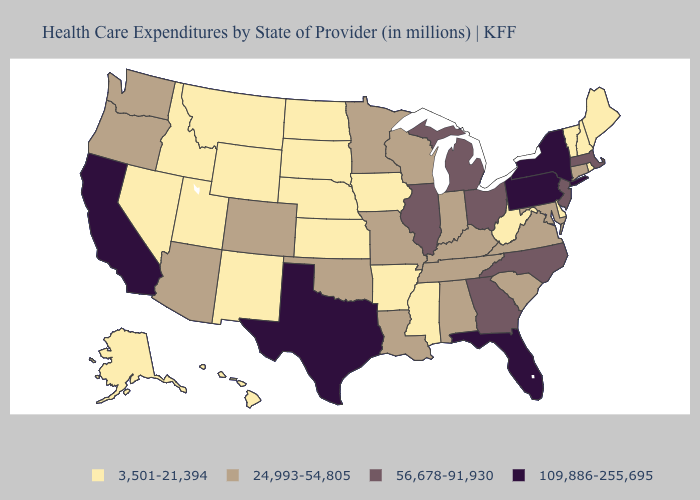Does Oregon have a lower value than Mississippi?
Answer briefly. No. What is the lowest value in the USA?
Short answer required. 3,501-21,394. Name the states that have a value in the range 56,678-91,930?
Quick response, please. Georgia, Illinois, Massachusetts, Michigan, New Jersey, North Carolina, Ohio. Name the states that have a value in the range 3,501-21,394?
Write a very short answer. Alaska, Arkansas, Delaware, Hawaii, Idaho, Iowa, Kansas, Maine, Mississippi, Montana, Nebraska, Nevada, New Hampshire, New Mexico, North Dakota, Rhode Island, South Dakota, Utah, Vermont, West Virginia, Wyoming. Is the legend a continuous bar?
Short answer required. No. Which states have the lowest value in the USA?
Give a very brief answer. Alaska, Arkansas, Delaware, Hawaii, Idaho, Iowa, Kansas, Maine, Mississippi, Montana, Nebraska, Nevada, New Hampshire, New Mexico, North Dakota, Rhode Island, South Dakota, Utah, Vermont, West Virginia, Wyoming. Does Illinois have the highest value in the MidWest?
Quick response, please. Yes. Does South Dakota have the highest value in the USA?
Concise answer only. No. Does Indiana have the highest value in the USA?
Answer briefly. No. What is the highest value in the South ?
Be succinct. 109,886-255,695. Name the states that have a value in the range 24,993-54,805?
Concise answer only. Alabama, Arizona, Colorado, Connecticut, Indiana, Kentucky, Louisiana, Maryland, Minnesota, Missouri, Oklahoma, Oregon, South Carolina, Tennessee, Virginia, Washington, Wisconsin. What is the highest value in the USA?
Be succinct. 109,886-255,695. Which states have the lowest value in the West?
Write a very short answer. Alaska, Hawaii, Idaho, Montana, Nevada, New Mexico, Utah, Wyoming. Which states have the highest value in the USA?
Short answer required. California, Florida, New York, Pennsylvania, Texas. What is the lowest value in the USA?
Answer briefly. 3,501-21,394. 